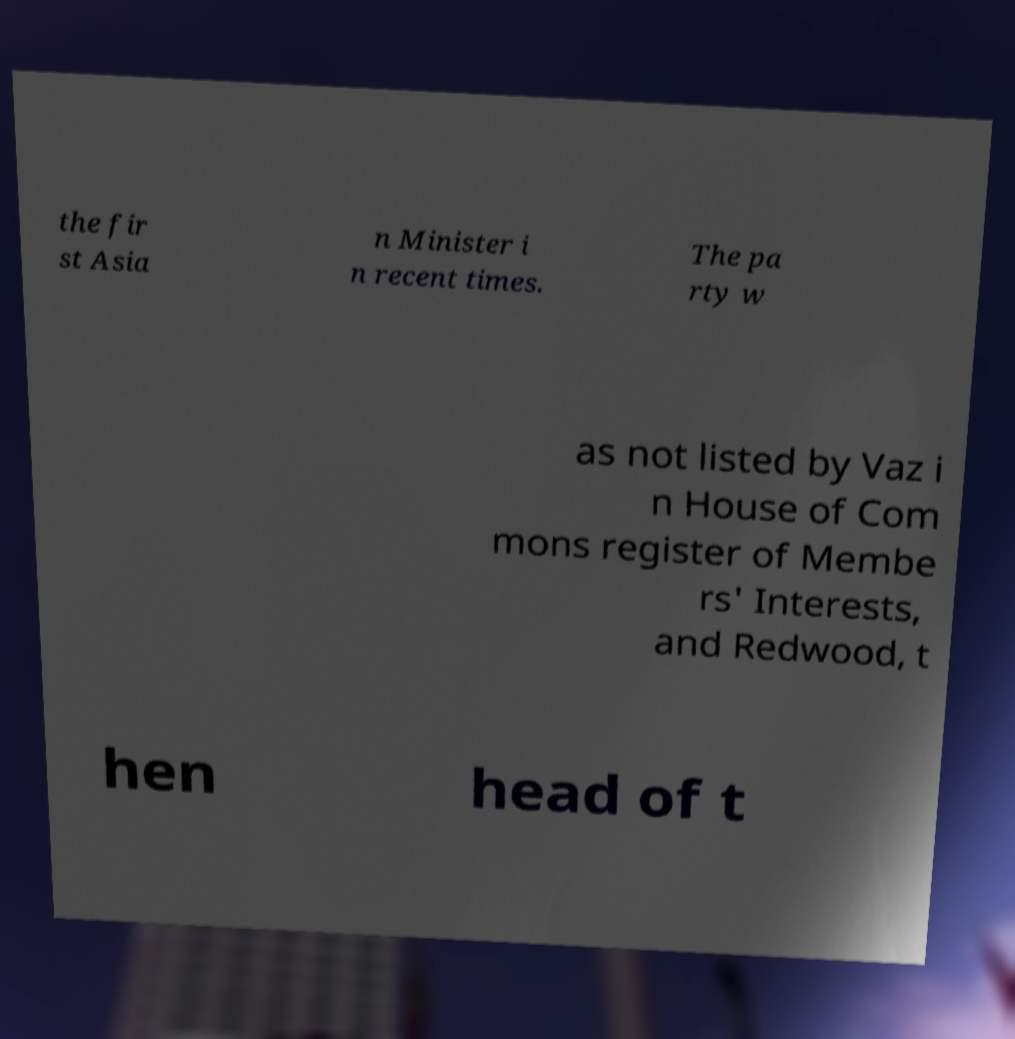For documentation purposes, I need the text within this image transcribed. Could you provide that? the fir st Asia n Minister i n recent times. The pa rty w as not listed by Vaz i n House of Com mons register of Membe rs' Interests, and Redwood, t hen head of t 